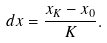<formula> <loc_0><loc_0><loc_500><loc_500>d x & = \frac { x _ { K } - x _ { 0 } } { K } .</formula> 